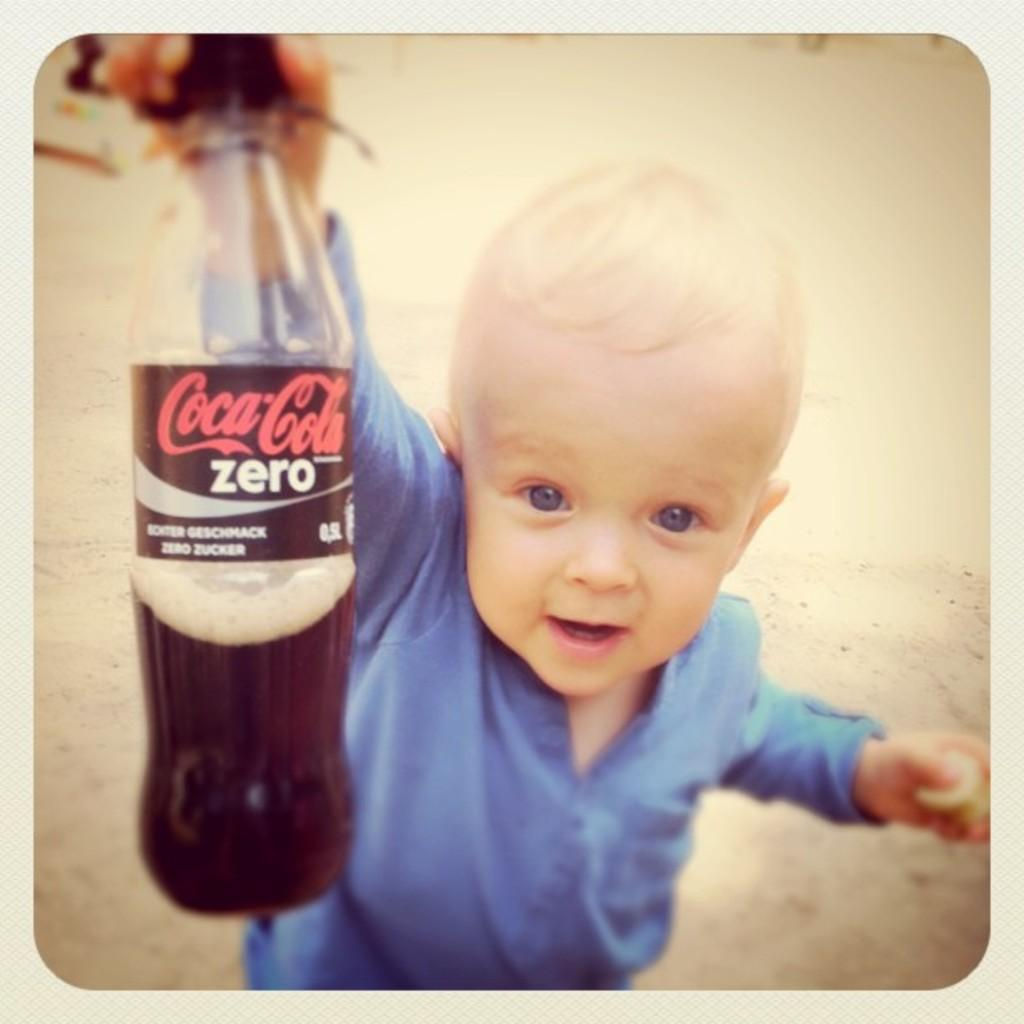What is the main subject of the image? There is a child in the image. What is the child wearing? The child is wearing a blue dress. What object is the child holding? The child is holding a Coca-Cola bottle. What can be seen in the background of the image? There is ground visible in the background of the image. What type of winter clothing is the child wearing in the image? There is no mention of winter or winter clothing in the image; the child is wearing a blue dress. What is the child's desire while holding the Coca-Cola bottle in the image? There is no information about the child's desires in the image; they are simply holding a Coca-Cola bottle. 